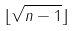Convert formula to latex. <formula><loc_0><loc_0><loc_500><loc_500>\lfloor \sqrt { n - 1 } \rfloor</formula> 